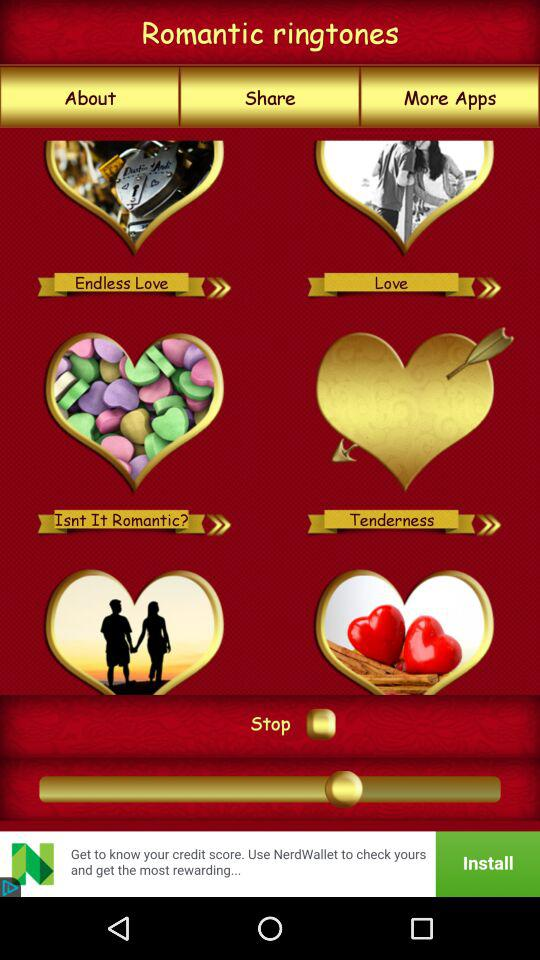How long is the "Tenderness" ringtone?
When the provided information is insufficient, respond with <no answer>. <no answer> 